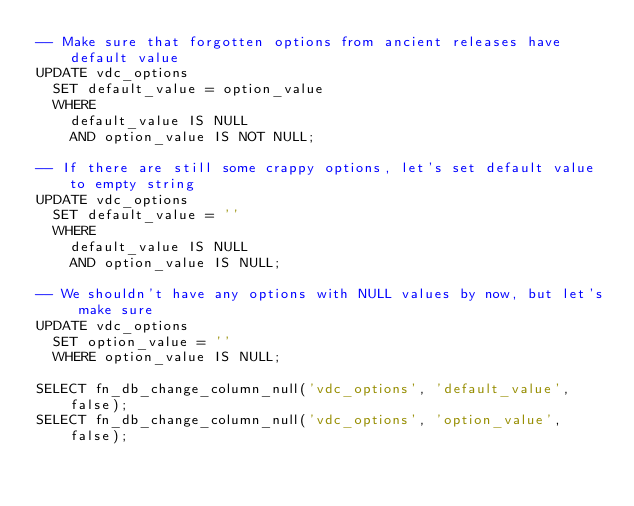Convert code to text. <code><loc_0><loc_0><loc_500><loc_500><_SQL_>-- Make sure that forgotten options from ancient releases have default value
UPDATE vdc_options
  SET default_value = option_value
  WHERE
    default_value IS NULL
    AND option_value IS NOT NULL;

-- If there are still some crappy options, let's set default value to empty string
UPDATE vdc_options
  SET default_value = ''
  WHERE
    default_value IS NULL
    AND option_value IS NULL;

-- We shouldn't have any options with NULL values by now, but let's make sure
UPDATE vdc_options
  SET option_value = ''
  WHERE option_value IS NULL;

SELECT fn_db_change_column_null('vdc_options', 'default_value', false);
SELECT fn_db_change_column_null('vdc_options', 'option_value', false);
</code> 